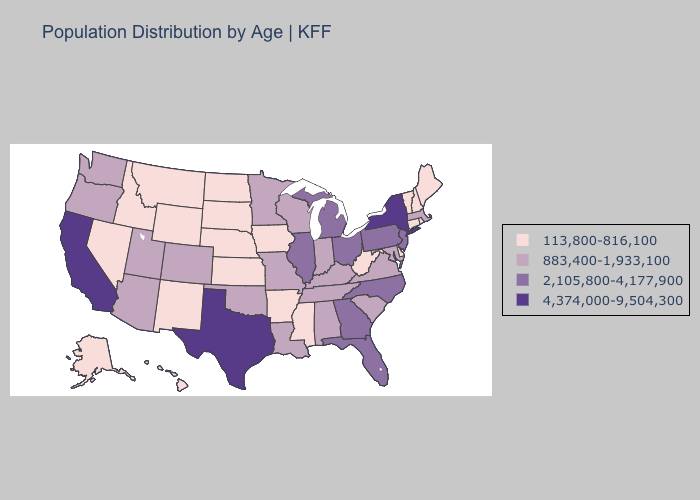What is the lowest value in the USA?
Concise answer only. 113,800-816,100. Name the states that have a value in the range 113,800-816,100?
Write a very short answer. Alaska, Arkansas, Connecticut, Delaware, Hawaii, Idaho, Iowa, Kansas, Maine, Mississippi, Montana, Nebraska, Nevada, New Hampshire, New Mexico, North Dakota, Rhode Island, South Dakota, Vermont, West Virginia, Wyoming. Name the states that have a value in the range 2,105,800-4,177,900?
Answer briefly. Florida, Georgia, Illinois, Michigan, New Jersey, North Carolina, Ohio, Pennsylvania. Does Utah have the highest value in the USA?
Quick response, please. No. What is the highest value in the Northeast ?
Keep it brief. 4,374,000-9,504,300. Among the states that border New Mexico , which have the highest value?
Quick response, please. Texas. Among the states that border Oklahoma , does Texas have the lowest value?
Quick response, please. No. What is the value of Oregon?
Answer briefly. 883,400-1,933,100. Among the states that border New Jersey , which have the highest value?
Keep it brief. New York. Does Arizona have the lowest value in the USA?
Concise answer only. No. Among the states that border Oklahoma , which have the highest value?
Quick response, please. Texas. Does South Carolina have the lowest value in the USA?
Answer briefly. No. What is the value of Maryland?
Keep it brief. 883,400-1,933,100. Does the first symbol in the legend represent the smallest category?
Keep it brief. Yes. What is the highest value in the Northeast ?
Give a very brief answer. 4,374,000-9,504,300. 